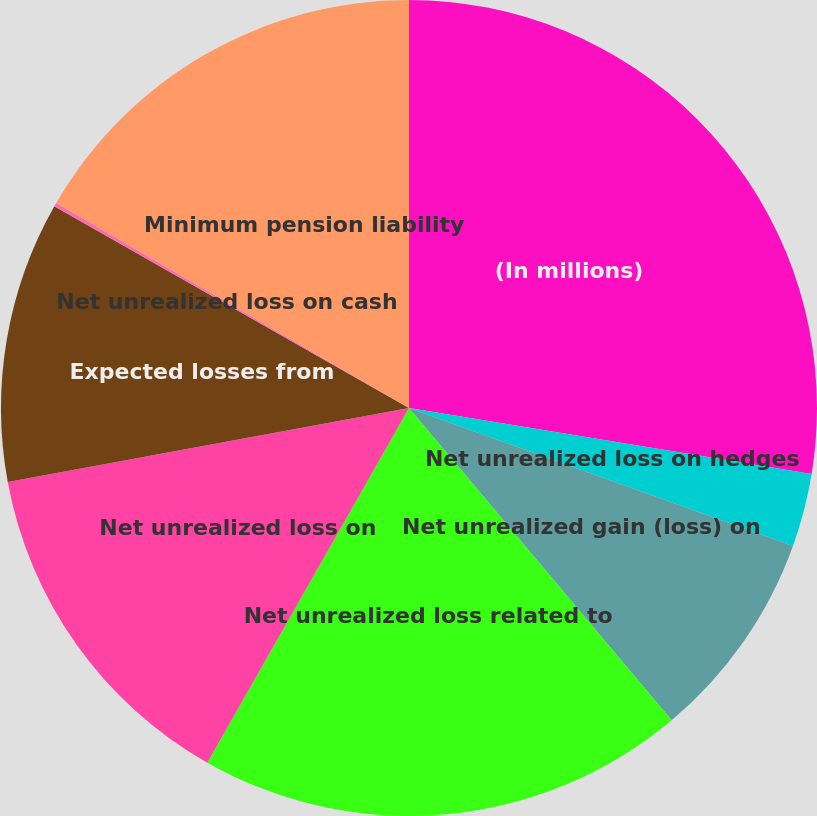Convert chart to OTSL. <chart><loc_0><loc_0><loc_500><loc_500><pie_chart><fcel>(In millions)<fcel>Net unrealized loss on hedges<fcel>Net unrealized gain (loss) on<fcel>Net unrealized loss related to<fcel>Net unrealized loss on<fcel>Expected losses from<fcel>Net unrealized loss on cash<fcel>Minimum pension liability<nl><fcel>27.59%<fcel>2.9%<fcel>8.38%<fcel>19.36%<fcel>13.87%<fcel>11.13%<fcel>0.15%<fcel>16.62%<nl></chart> 